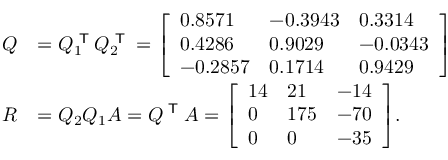Convert formula to latex. <formula><loc_0><loc_0><loc_500><loc_500>{ \begin{array} { r l } { Q } & { = Q _ { 1 } ^ { T } Q _ { 2 } ^ { T } = { \left [ \begin{array} { l l l } { 0 . 8 5 7 1 } & { - 0 . 3 9 4 3 } & { 0 . 3 3 1 4 } \\ { 0 . 4 2 8 6 } & { 0 . 9 0 2 9 } & { - 0 . 0 3 4 3 } \\ { - 0 . 2 8 5 7 } & { 0 . 1 7 1 4 } & { 0 . 9 4 2 9 } \end{array} \right ] } } \\ { R } & { = Q _ { 2 } Q _ { 1 } A = Q ^ { T } A = { \left [ \begin{array} { l l l } { 1 4 } & { 2 1 } & { - 1 4 } \\ { 0 } & { 1 7 5 } & { - 7 0 } \\ { 0 } & { 0 } & { - 3 5 } \end{array} \right ] } . } \end{array} }</formula> 